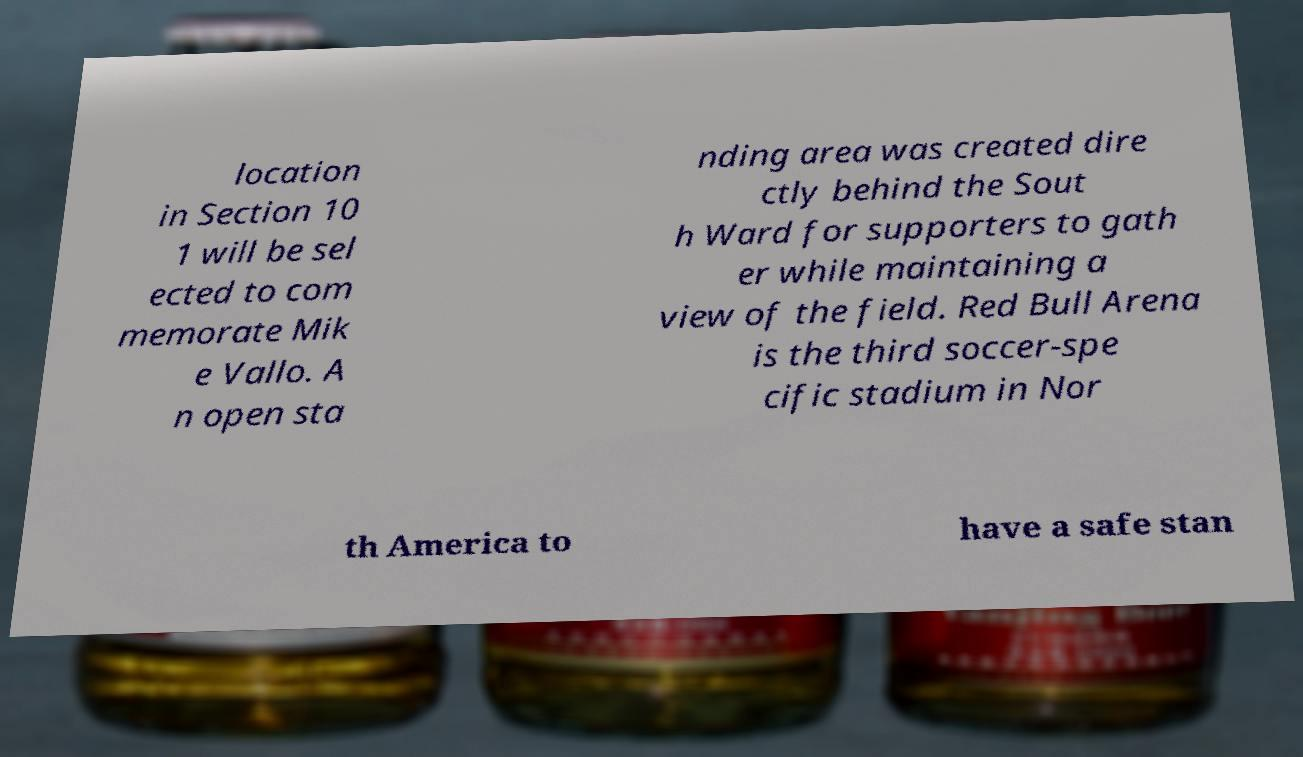Can you read and provide the text displayed in the image?This photo seems to have some interesting text. Can you extract and type it out for me? location in Section 10 1 will be sel ected to com memorate Mik e Vallo. A n open sta nding area was created dire ctly behind the Sout h Ward for supporters to gath er while maintaining a view of the field. Red Bull Arena is the third soccer-spe cific stadium in Nor th America to have a safe stan 